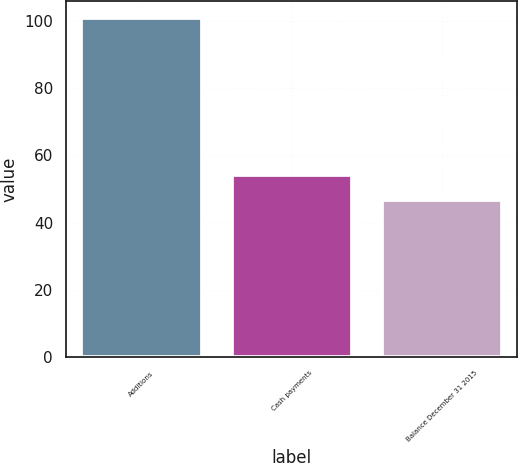Convert chart to OTSL. <chart><loc_0><loc_0><loc_500><loc_500><bar_chart><fcel>Additions<fcel>Cash payments<fcel>Balance December 31 2015<nl><fcel>101<fcel>54.1<fcel>46.8<nl></chart> 